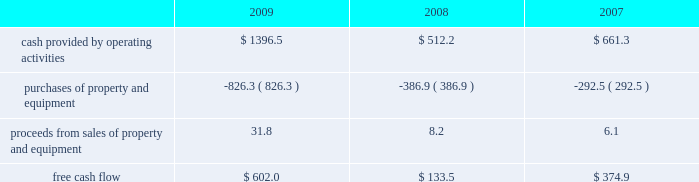Failure to comply with the financial and other covenants under our credit facilities , as well as the occurrence of certain material adverse events , would constitute defaults and would allow the lenders under our credit facilities to accelerate the maturity of all indebtedness under the related agreements .
This could also have an adverse impact on the availability of financial assurances .
In addition , maturity acceleration on our credit facilities constitutes an event of default under our other debt instruments , including our senior notes , and , therefore , our senior notes would also be subject to acceleration of maturity .
If such acceleration were to occur , we would not have sufficient liquidity available to repay the indebtedness .
We would likely have to seek an amendment under our credit facilities for relief from the financial covenants or repay the debt with proceeds from the issuance of new debt or equity , or asset sales , if necessary .
We may be unable to amend our credit facilities or raise sufficient capital to repay such obligations in the event the maturities are accelerated .
Financial assurance we are required to provide financial assurance to governmental agencies and a variety of other entities under applicable environmental regulations relating to our landfill operations for capping , closure and post-closure costs , and related to our performance under certain collection , landfill and transfer station contracts .
We satisfy these financial assurance requirements by providing surety bonds , letters of credit , insurance policies or trust deposits .
The amount of the financial assurance requirements for capping , closure and post-closure costs is determined by applicable state environmental regulations .
The financial assurance requirements for capping , closure and post-closure costs may be associated with a portion of the landfill or the entire landfill .
Generally , states will require a third-party engineering specialist to determine the estimated capping , closure and post- closure costs that are used to determine the required amount of financial assurance for a landfill .
The amount of financial assurance required can , and generally will , differ from the obligation determined and recorded under u.s .
Gaap .
The amount of the financial assurance requirements related to contract performance varies by contract .
Additionally , we are required to provide financial assurance for our insurance program and collateral for certain performance obligations .
We do not expect a material increase in financial assurance requirements during 2010 , although the mix of financial assurance instruments may change .
These financial instruments are issued in the normal course of business and are not debt of our company .
Since we currently have no liability for these financial assurance instruments , they are not reflected in our consolidated balance sheets .
However , we record capping , closure and post-closure liabilities and self-insurance liabilities as they are incurred .
The underlying obligations of the financial assurance instruments , in excess of those already reflected in our consolidated balance sheets , would be recorded if it is probable that we would be unable to fulfill our related obligations .
We do not expect this to occur .
Off-balance sheet arrangements we have no off-balance sheet debt or similar obligations , other than financial assurance instruments and operating leases that are not classified as debt .
We do not guarantee any third-party debt .
Free cash flow we define free cash flow , which is not a measure determined in accordance with u.s .
Gaap , as cash provided by operating activities less purchases of property and equipment , plus proceeds from sales of property and equipment as presented in our consolidated statements of cash flows .
Our free cash flow for the years ended december 31 , 2009 , 2008 and 2007 is calculated as follows ( in millions ) : .

What was the change in the free cash flow from 2008 to 2009 in millions? 
Rationale: the change is the difference between the two amounts
Computations: (602.0 - 133.5)
Answer: 468.5. 